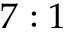Convert formula to latex. <formula><loc_0><loc_0><loc_500><loc_500>7 \colon 1</formula> 